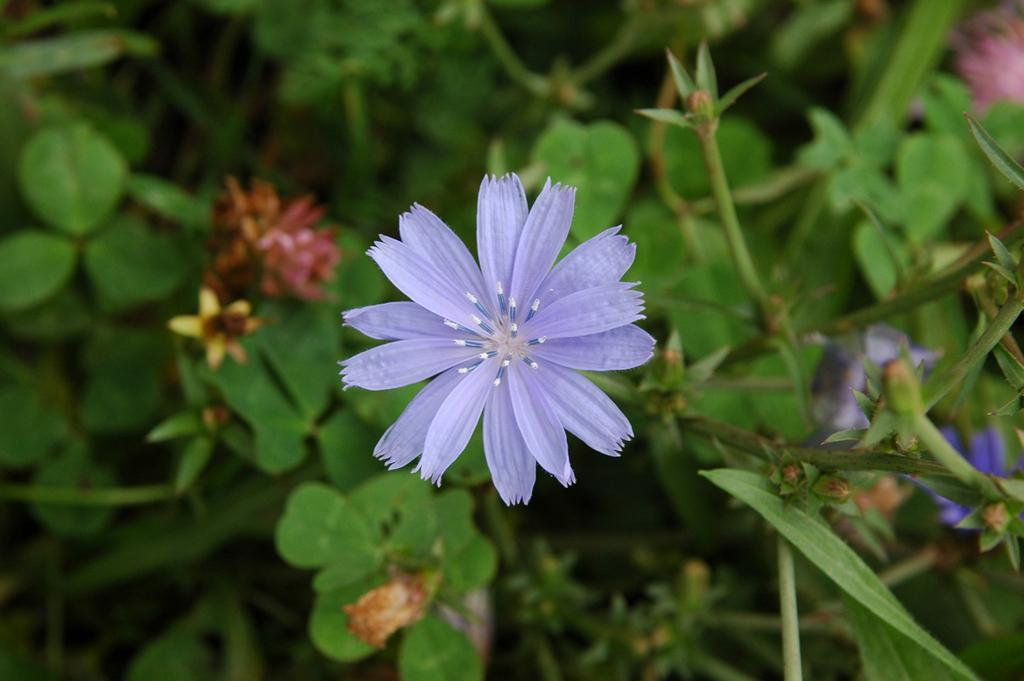What type of living organisms can be seen in the image? There are flowers and plants in the image. Can you describe the plants in the image? The plants in the image are not specified, but they are present alongside the flowers. What type of wool is used to make the flowers in the image? There is no wool present in the image, as the flowers are likely real or depicted as such. 